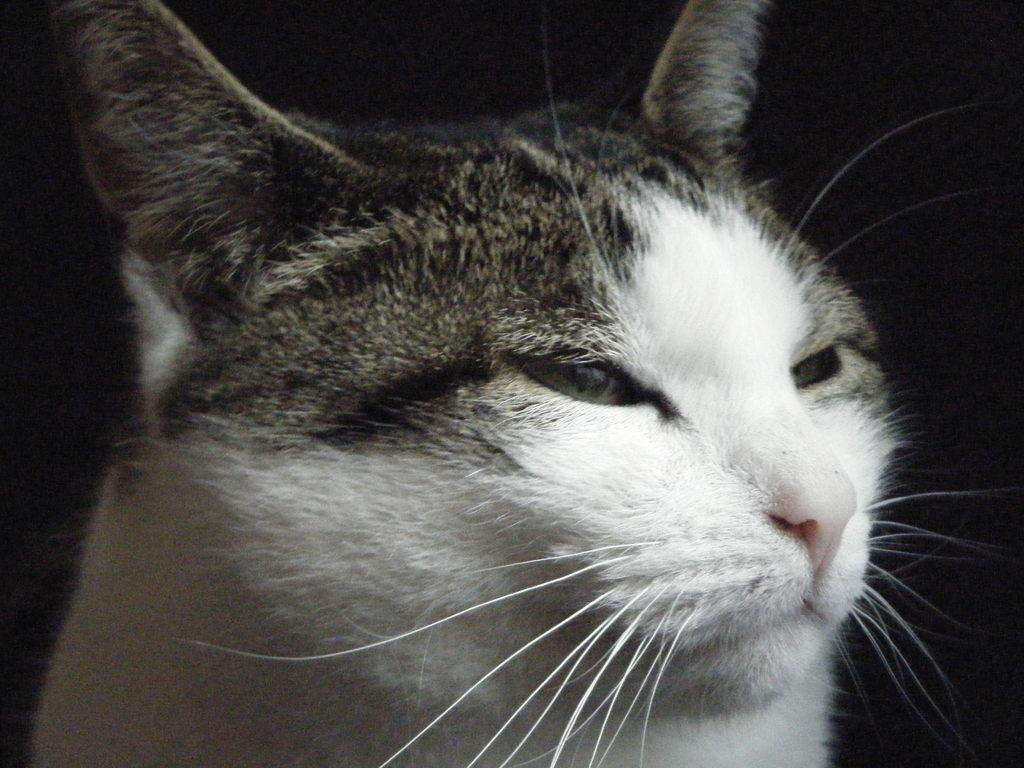What is the color of the background in the image? The background of the image is dark. What is the main subject in the image? There is a cat in the middle of the image. Can you hear the cat in the image? The image is not accompanied by sound, so it is not possible to hear the cat. 